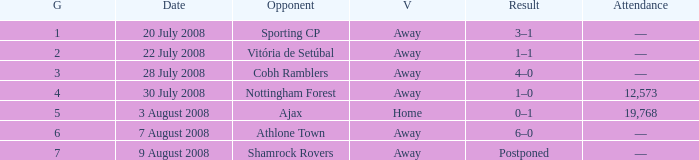What is the result on 20 July 2008? 3–1. 